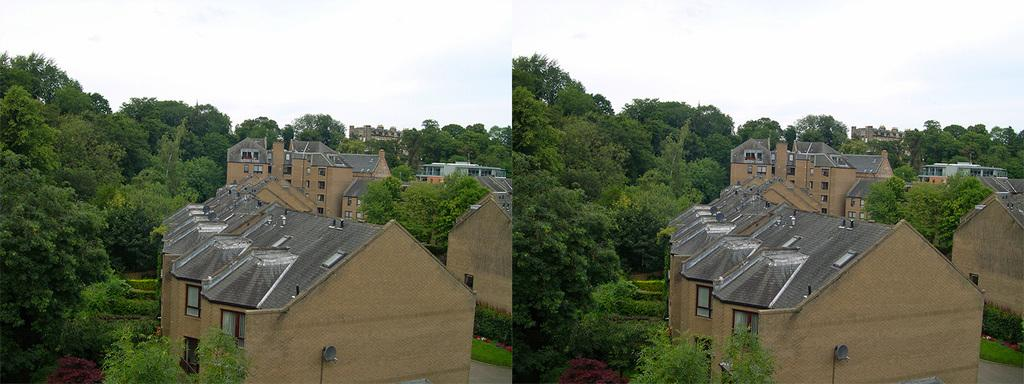What type of artwork is the image? The image is a collage. What can be found in the middle of the collage? There are houses in the middle of the collage. What type of natural elements are present in the collage? There are many trees in the collage. What part of the natural environment is visible in the background of the collage? The sky is visible in the background of the collage. What type of yarn is being used to create the carriage in the collage? There is no carriage present in the collage; it features houses and trees. What type of voice can be heard coming from the trees in the collage? There is no sound or voice present in the collage; it is a visual representation of houses, trees, and the sky. 